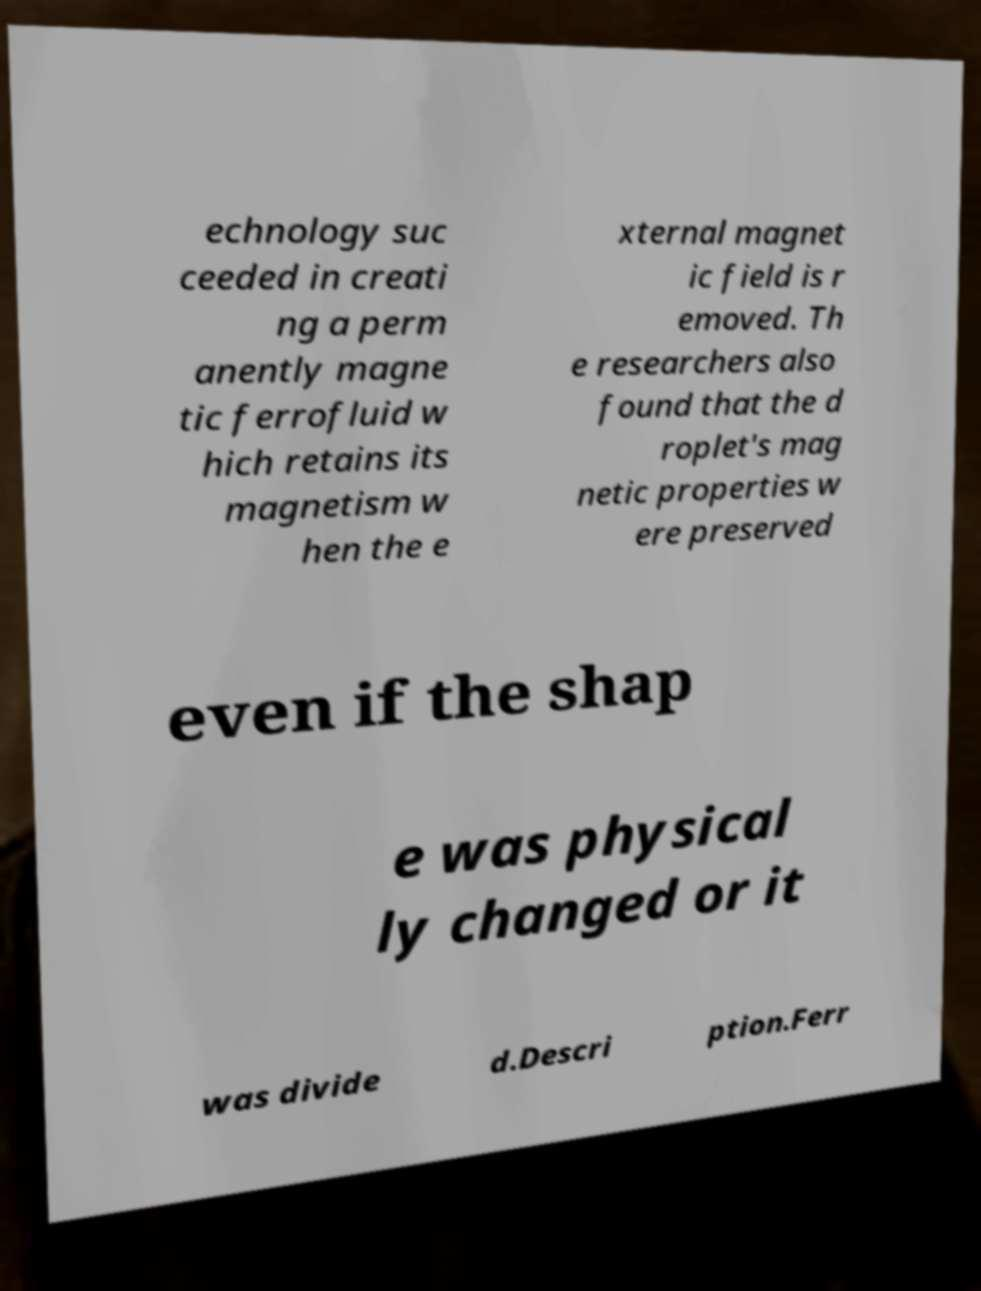Please read and relay the text visible in this image. What does it say? echnology suc ceeded in creati ng a perm anently magne tic ferrofluid w hich retains its magnetism w hen the e xternal magnet ic field is r emoved. Th e researchers also found that the d roplet's mag netic properties w ere preserved even if the shap e was physical ly changed or it was divide d.Descri ption.Ferr 